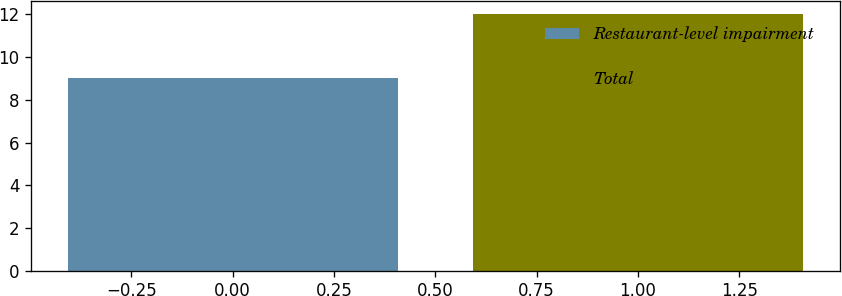Convert chart. <chart><loc_0><loc_0><loc_500><loc_500><bar_chart><fcel>Restaurant-level impairment<fcel>Total<nl><fcel>9<fcel>12<nl></chart> 